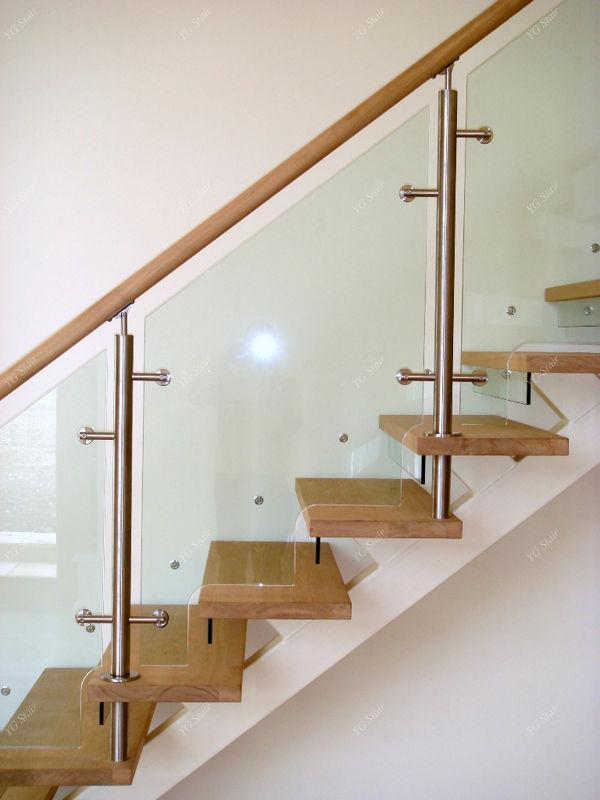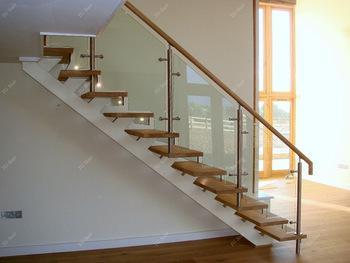The first image is the image on the left, the second image is the image on the right. Analyze the images presented: Is the assertion "In at least one image there is a staircase facing left with three separate glass panels held up by a light brown rail." valid? Answer yes or no. Yes. The first image is the image on the left, the second image is the image on the right. Given the left and right images, does the statement "Each image shows a staircase that is open underneath and ascends in one diagonal line, without turning and with no upper railed landing." hold true? Answer yes or no. Yes. 